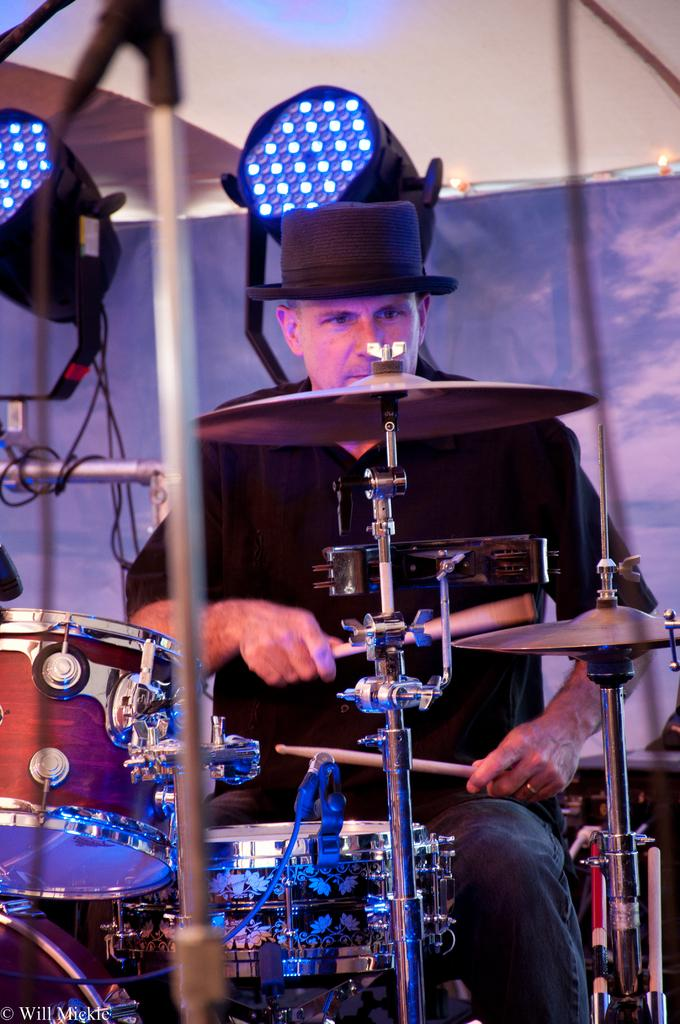What is the man in the image doing? The man is playing drums in the image. What is the man holding in his hands? The man is holding sticks in his hands. What color is the shirt the man is wearing? The man is wearing a black shirt. What type of headwear is the man wearing? The man is wearing a black hat. What can be seen in the background of the image? There is a wall in the background of the image. Can you tell me how many flowers are in the garden behind the man? There is no garden visible in the image, so it is not possible to determine the number of flowers present. 